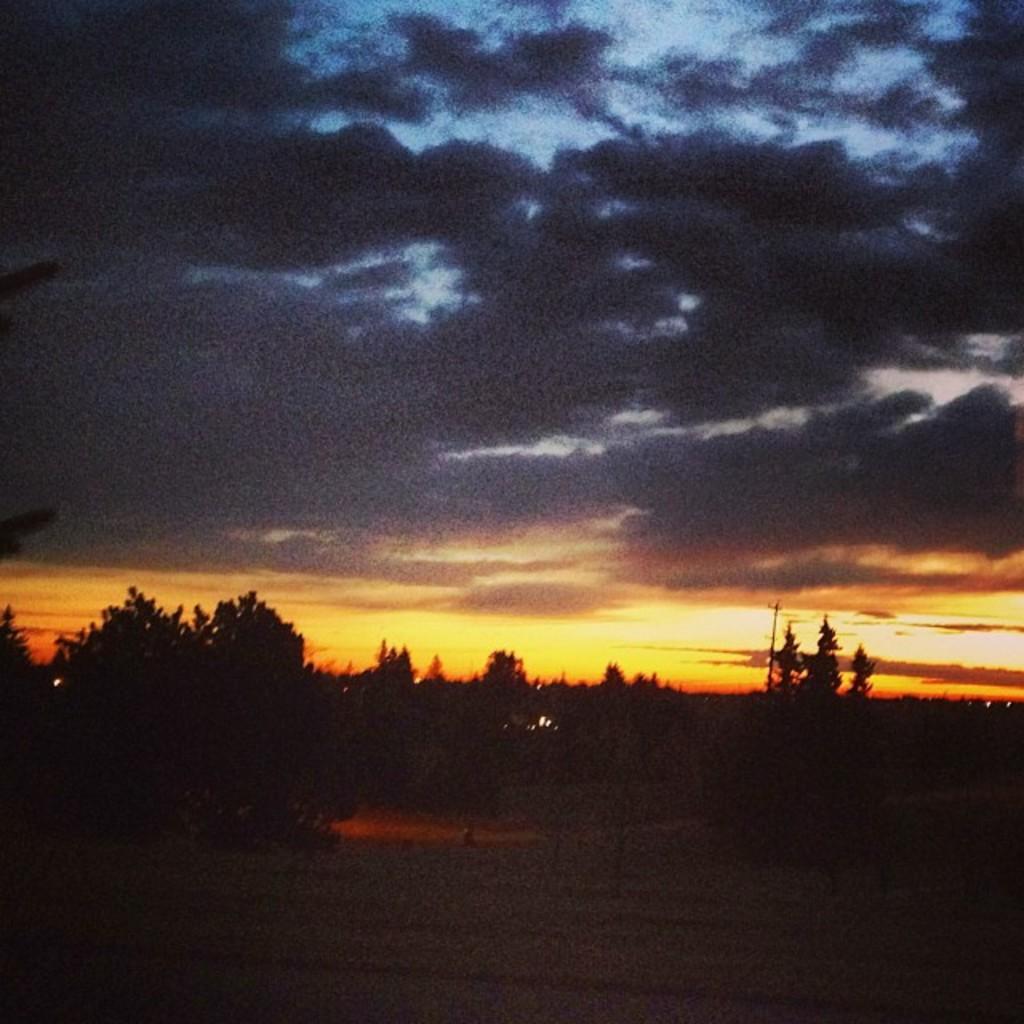Please provide a concise description of this image. In this image I can see the dark image in which I can see the ground, few trees and in the background I can see the sky which is black, blue, yellow and orange in color. 